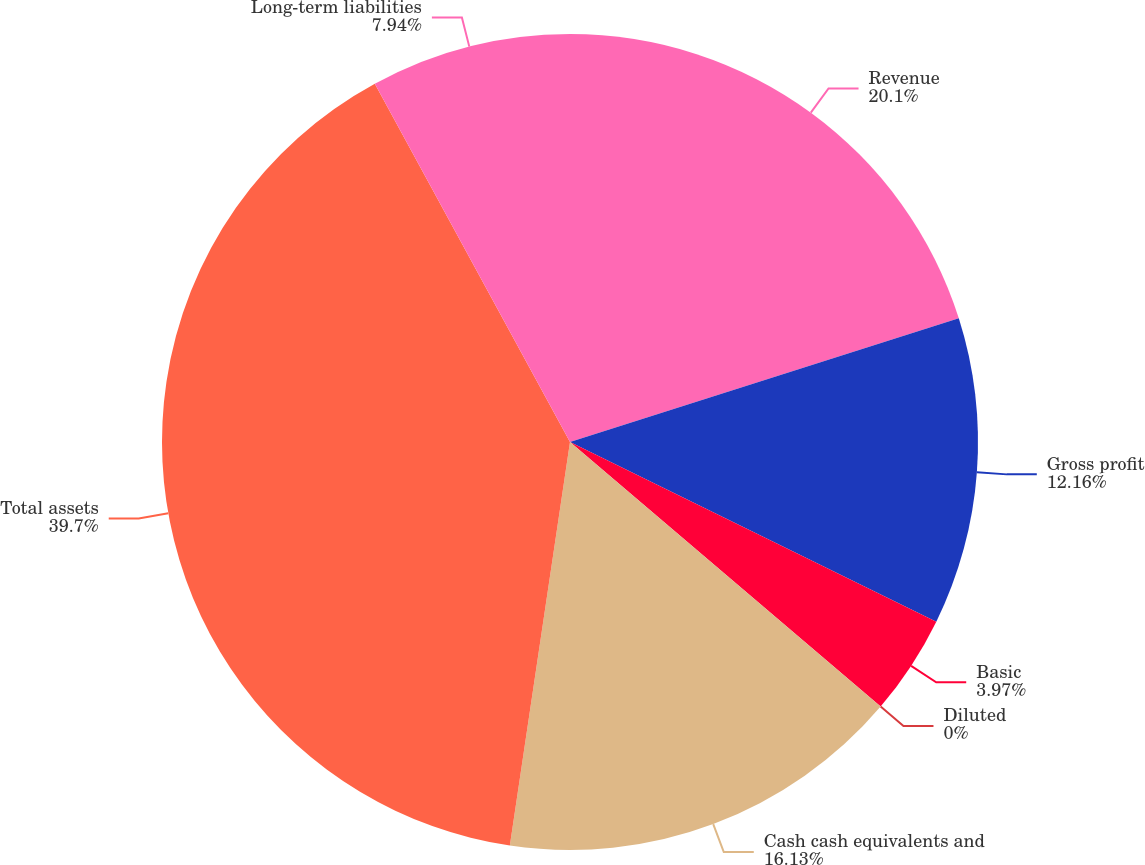Convert chart to OTSL. <chart><loc_0><loc_0><loc_500><loc_500><pie_chart><fcel>Revenue<fcel>Gross profit<fcel>Basic<fcel>Diluted<fcel>Cash cash equivalents and<fcel>Total assets<fcel>Long-term liabilities<nl><fcel>20.1%<fcel>12.16%<fcel>3.97%<fcel>0.0%<fcel>16.13%<fcel>39.71%<fcel>7.94%<nl></chart> 